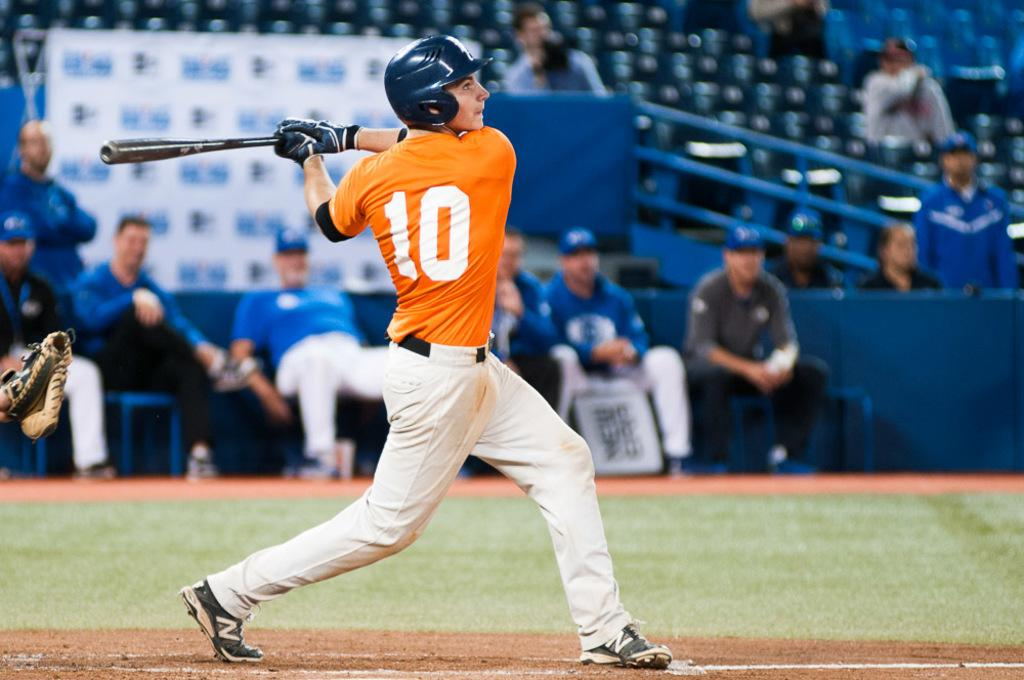<image>
Render a clear and concise summary of the photo. Player number 10 in orange swings at a baseball. 